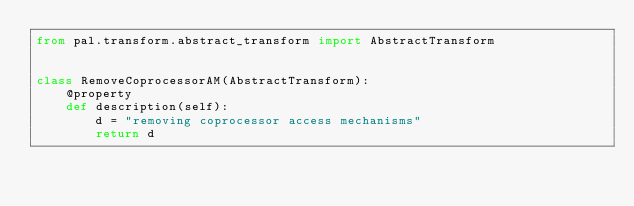<code> <loc_0><loc_0><loc_500><loc_500><_Python_>from pal.transform.abstract_transform import AbstractTransform


class RemoveCoprocessorAM(AbstractTransform):
    @property
    def description(self):
        d = "removing coprocessor access mechanisms"
        return d
</code> 